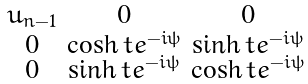Convert formula to latex. <formula><loc_0><loc_0><loc_500><loc_500>\begin{smallmatrix} u _ { n - 1 } & 0 & 0 \\ 0 & \cosh t e ^ { - i \psi } & \sinh t e ^ { - i \psi } \\ 0 & \sinh t e ^ { - i \psi } & \cosh t e ^ { - i \psi } \end{smallmatrix}</formula> 